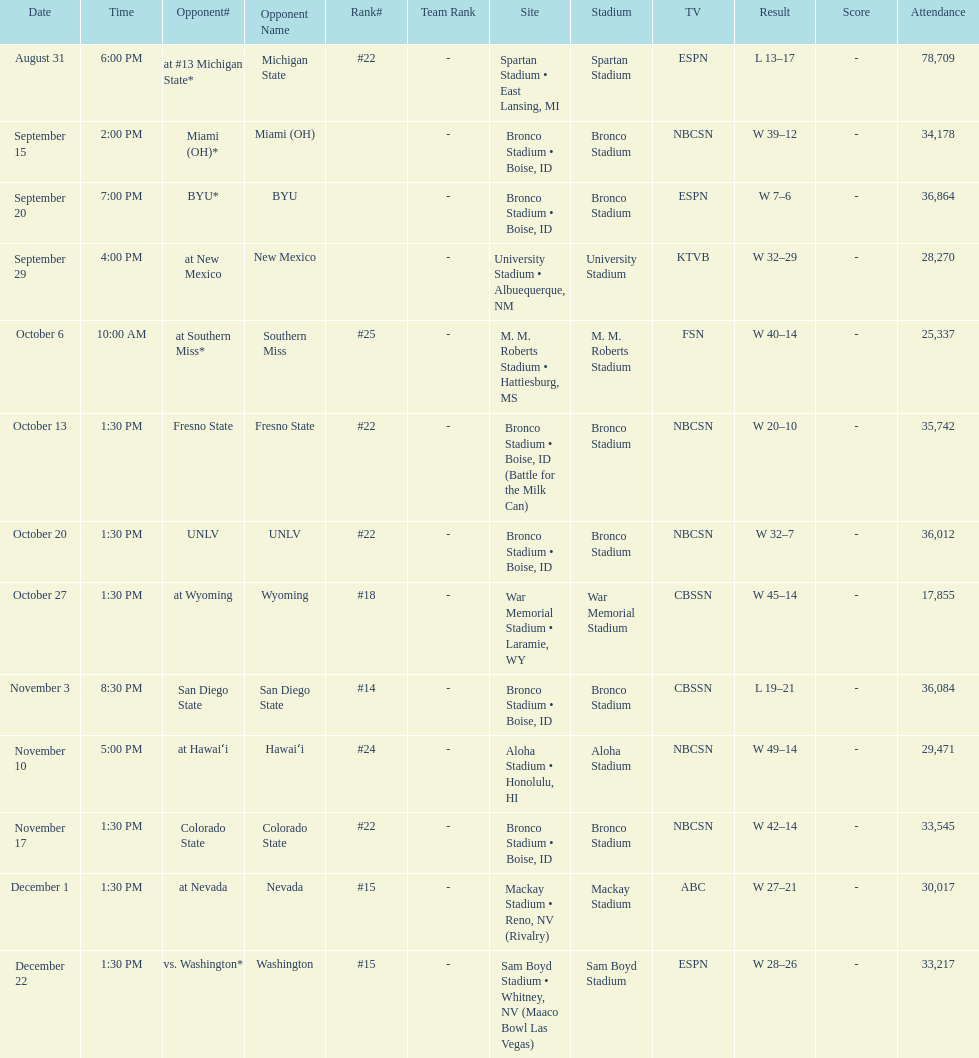Could you help me parse every detail presented in this table? {'header': ['Date', 'Time', 'Opponent#', 'Opponent Name', 'Rank#', 'Team Rank', 'Site', 'Stadium', 'TV', 'Result', 'Score', 'Attendance'], 'rows': [['August 31', '6:00 PM', 'at\xa0#13\xa0Michigan State*', 'Michigan State', '#22', '-', 'Spartan Stadium • East Lansing, MI', 'Spartan Stadium', 'ESPN', 'L\xa013–17', '-', '78,709'], ['September 15', '2:00 PM', 'Miami (OH)*', 'Miami (OH)', '', '-', 'Bronco Stadium • Boise, ID', 'Bronco Stadium', 'NBCSN', 'W\xa039–12', '-', '34,178'], ['September 20', '7:00 PM', 'BYU*', 'BYU', '', '-', 'Bronco Stadium • Boise, ID', 'Bronco Stadium', 'ESPN', 'W\xa07–6', '-', '36,864'], ['September 29', '4:00 PM', 'at\xa0New Mexico', 'New Mexico', '', '-', 'University Stadium • Albuequerque, NM', 'University Stadium', 'KTVB', 'W\xa032–29', '-', '28,270'], ['October 6', '10:00 AM', 'at\xa0Southern Miss*', 'Southern Miss', '#25', '-', 'M. M. Roberts Stadium • Hattiesburg, MS', 'M. M. Roberts Stadium', 'FSN', 'W\xa040–14', '-', '25,337'], ['October 13', '1:30 PM', 'Fresno State', 'Fresno State', '#22', '-', 'Bronco Stadium • Boise, ID (Battle for the Milk Can)', 'Bronco Stadium', 'NBCSN', 'W\xa020–10', '-', '35,742'], ['October 20', '1:30 PM', 'UNLV', 'UNLV', '#22', '-', 'Bronco Stadium • Boise, ID', 'Bronco Stadium', 'NBCSN', 'W\xa032–7', '-', '36,012'], ['October 27', '1:30 PM', 'at\xa0Wyoming', 'Wyoming', '#18', '-', 'War Memorial Stadium • Laramie, WY', 'War Memorial Stadium', 'CBSSN', 'W\xa045–14', '-', '17,855'], ['November 3', '8:30 PM', 'San Diego State', 'San Diego State', '#14', '-', 'Bronco Stadium • Boise, ID', 'Bronco Stadium', 'CBSSN', 'L\xa019–21', '-', '36,084'], ['November 10', '5:00 PM', 'at\xa0Hawaiʻi', 'Hawaiʻi', '#24', '-', 'Aloha Stadium • Honolulu, HI', 'Aloha Stadium', 'NBCSN', 'W\xa049–14', '-', '29,471'], ['November 17', '1:30 PM', 'Colorado State', 'Colorado State', '#22', '-', 'Bronco Stadium • Boise, ID', 'Bronco Stadium', 'NBCSN', 'W\xa042–14', '-', '33,545'], ['December 1', '1:30 PM', 'at\xa0Nevada', 'Nevada', '#15', '-', 'Mackay Stadium • Reno, NV (Rivalry)', 'Mackay Stadium', 'ABC', 'W\xa027–21', '-', '30,017'], ['December 22', '1:30 PM', 'vs.\xa0Washington*', 'Washington', '#15', '-', 'Sam Boyd Stadium • Whitney, NV (Maaco Bowl Las Vegas)', 'Sam Boyd Stadium', 'ESPN', 'W\xa028–26', '-', '33,217']]} Opponent broncos faced next after unlv Wyoming. 